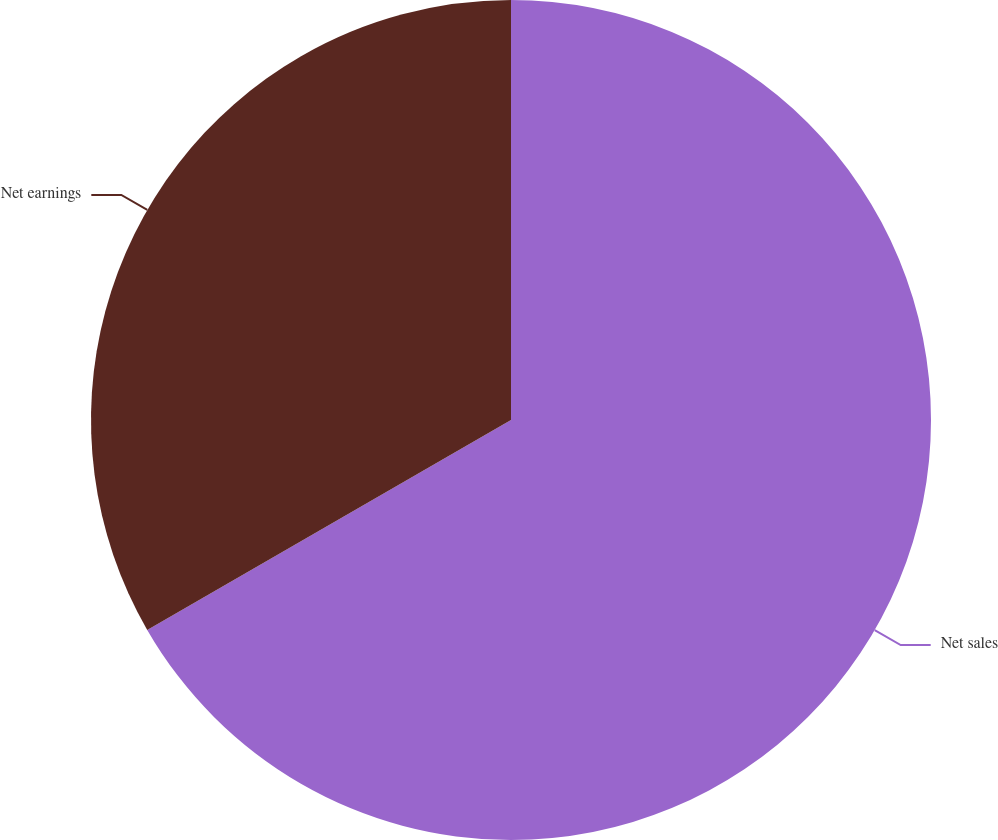Convert chart. <chart><loc_0><loc_0><loc_500><loc_500><pie_chart><fcel>Net sales<fcel>Net earnings<nl><fcel>66.67%<fcel>33.33%<nl></chart> 